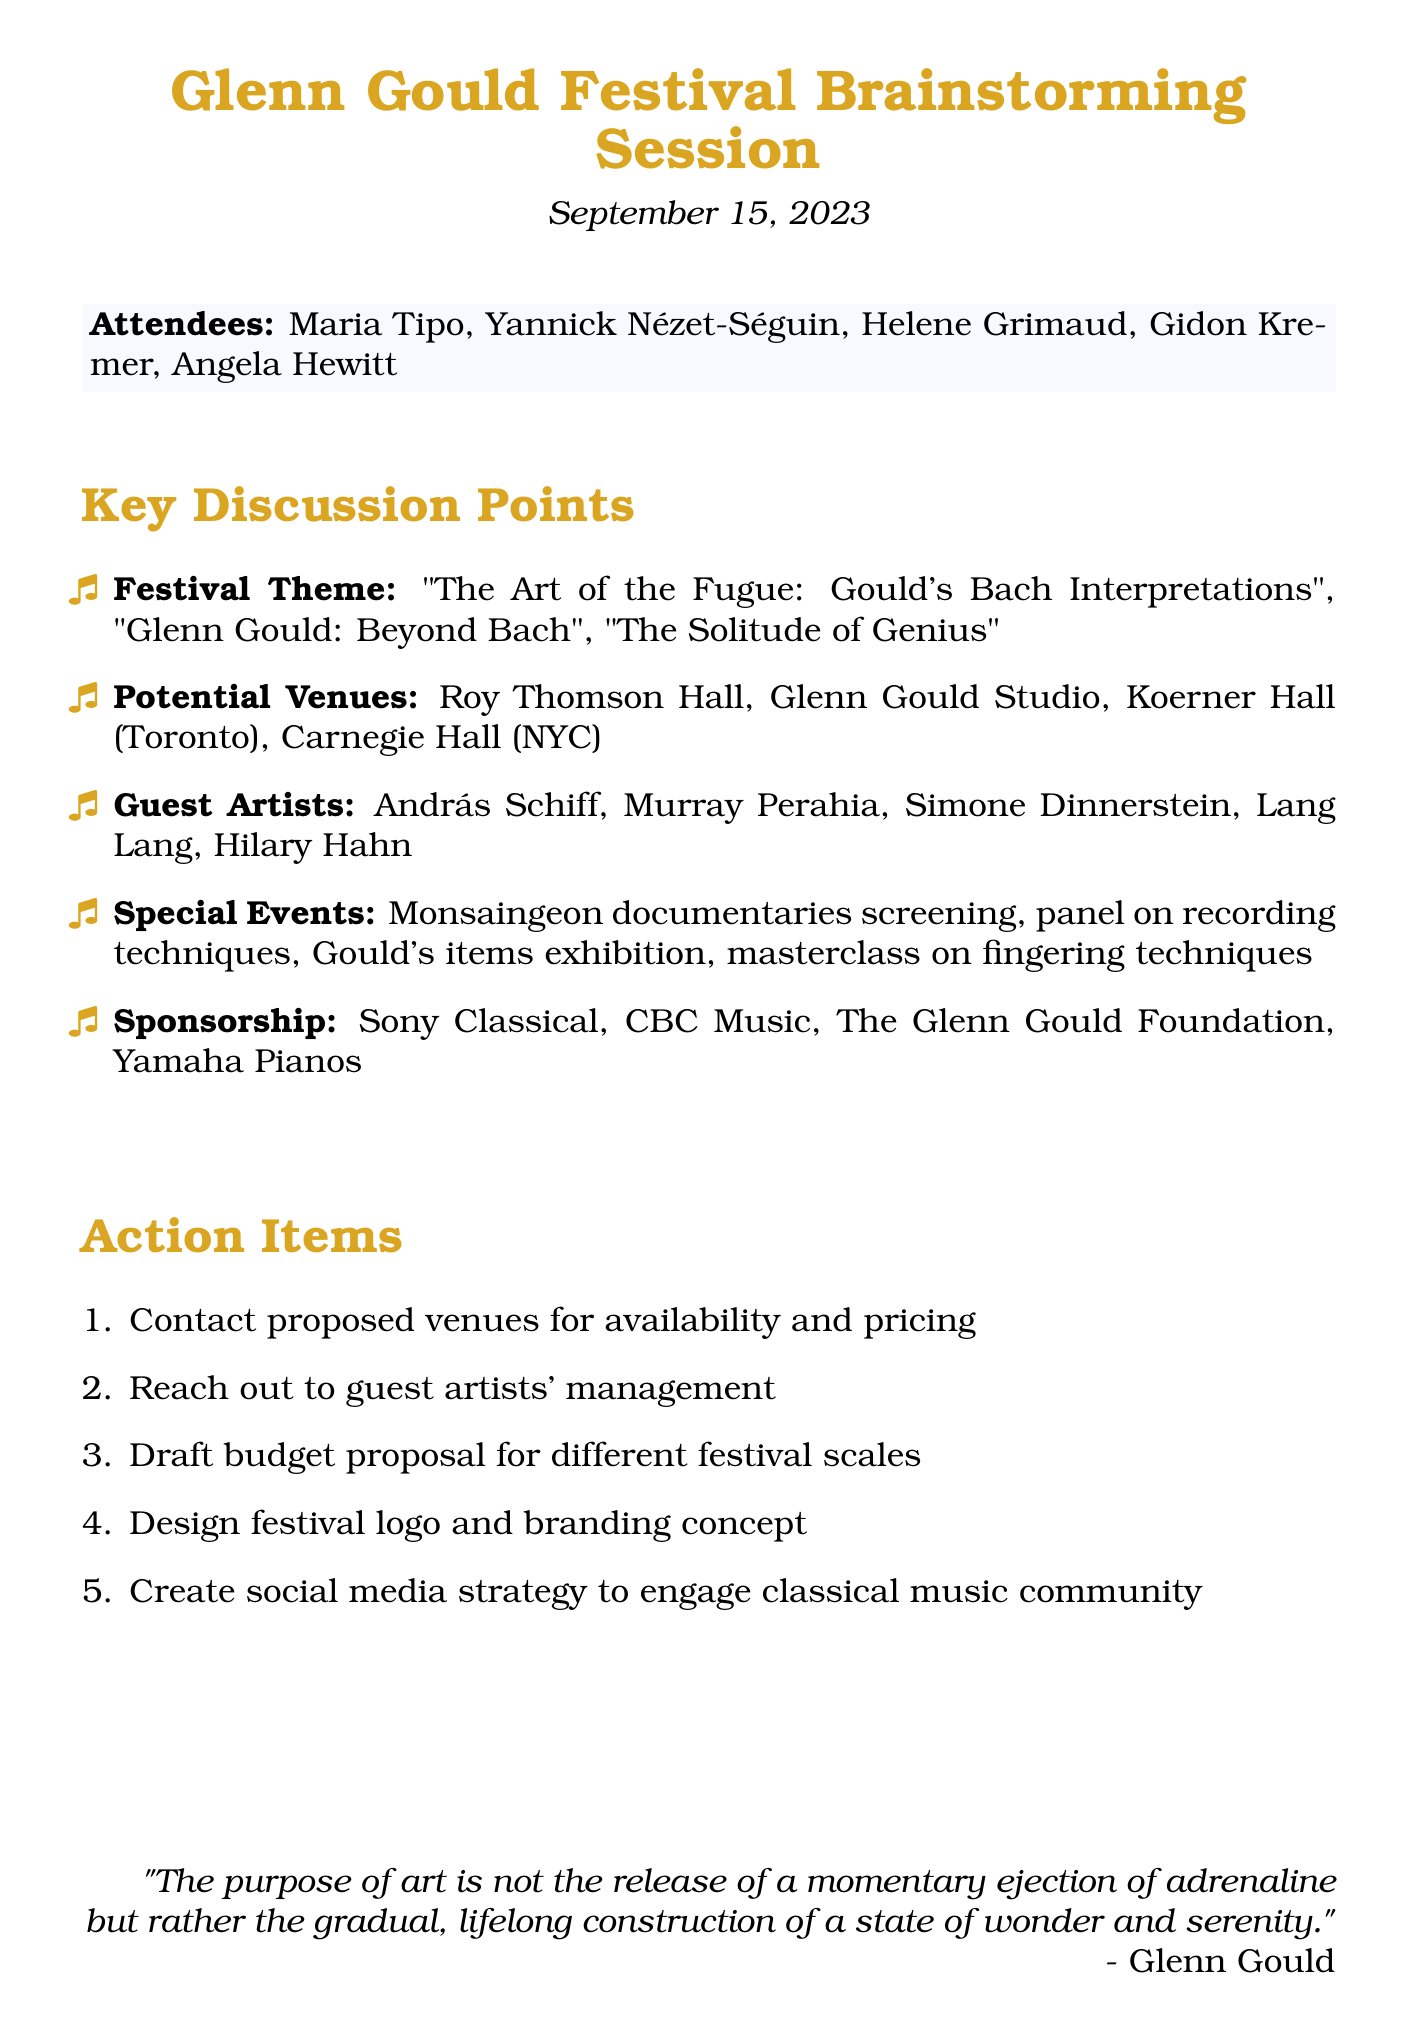What is the date of the meeting? The date is specified at the beginning of the document as September 15, 2023.
Answer: September 15, 2023 Who is one of the proposed guest artists? The document lists several proposed guest artists, including András Schiff.
Answer: András Schiff Which venue is located in New York City? The venues are listed, and Carnegie Hall is mentioned as being in New York City.
Answer: Carnegie Hall What is one of the special event ideas proposed? The document outlines special events, including a panel discussion on Gould's recording techniques.
Answer: Panel discussion on Gould's recording techniques How many attendees were present at the meeting? The document lists five attendees participating in the session.
Answer: Five What topic covers Gould's lesser-known recordings? One of the festival themes discussed was "Glenn Gould: Beyond Bach - Exploring his lesser-known recordings."
Answer: Glenn Gould: Beyond Bach What is one potential partner for sponsorship? The document mentions several potential partners, one of which is Sony Classical.
Answer: Sony Classical What action item involves contacting venues? One of the action items states to contact proposed venues for availability and pricing.
Answer: Contact proposed venues for availability and pricing 